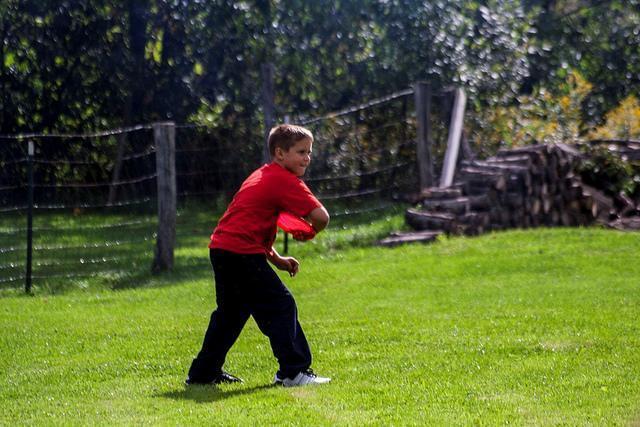How many people can you see?
Give a very brief answer. 1. 